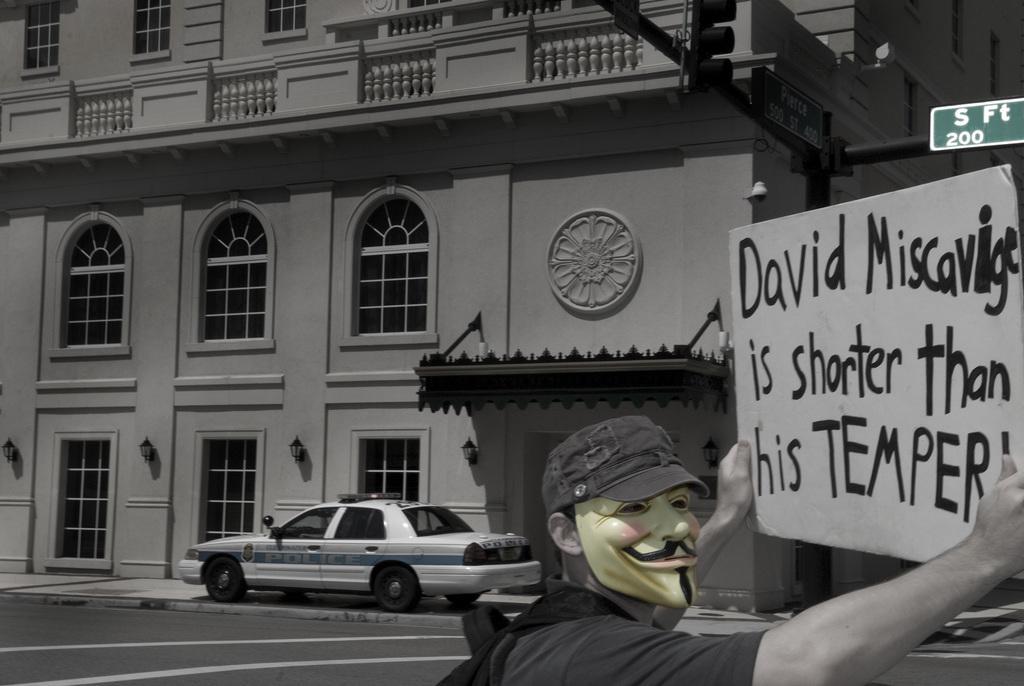Please provide a concise description of this image. In the image we can see in front there is a person standing and he is holding a banner in his hand. Behind there is a car parked on the road and there is a building. The image is in black and white colour. 